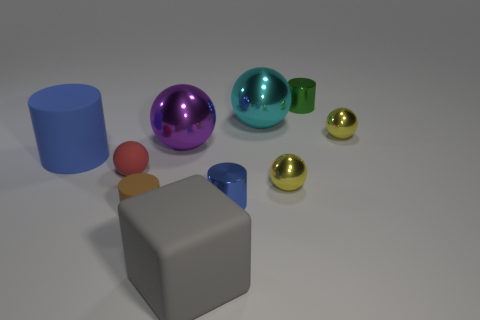Subtract all small rubber balls. How many balls are left? 4 Subtract all yellow blocks. How many yellow balls are left? 2 Subtract 2 cylinders. How many cylinders are left? 2 Subtract all green cylinders. How many cylinders are left? 3 Subtract all cubes. How many objects are left? 9 Add 3 blue metal cubes. How many blue metal cubes exist? 3 Subtract 0 yellow cylinders. How many objects are left? 10 Subtract all blue cylinders. Subtract all gray cubes. How many cylinders are left? 2 Subtract all large blue matte cylinders. Subtract all big gray matte objects. How many objects are left? 8 Add 7 cyan metallic spheres. How many cyan metallic spheres are left? 8 